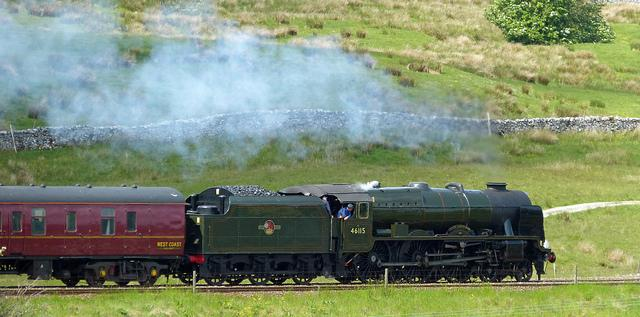Which car propels the train along the tracks? Please explain your reasoning. front. The front car propels. 